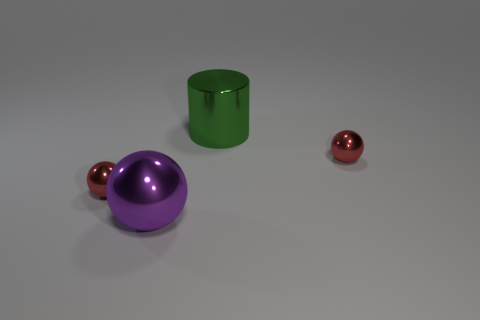What material do the objects in the image appear to be made of? The objects in the image have a reflective surface, suggesting they might be made from a polished metal or a similarly reflective plastic. 